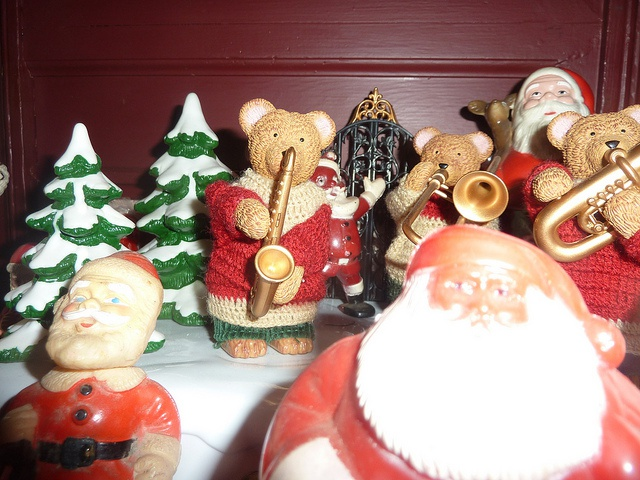Describe the objects in this image and their specific colors. I can see teddy bear in black, khaki, tan, brown, and beige tones, teddy bear in black, tan, khaki, ivory, and brown tones, and teddy bear in black, tan, ivory, and gray tones in this image. 